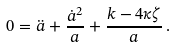Convert formula to latex. <formula><loc_0><loc_0><loc_500><loc_500>0 = \ddot { a } + \frac { \dot { a } ^ { 2 } } { a } + \frac { k - 4 \kappa \zeta } { a } \, .</formula> 